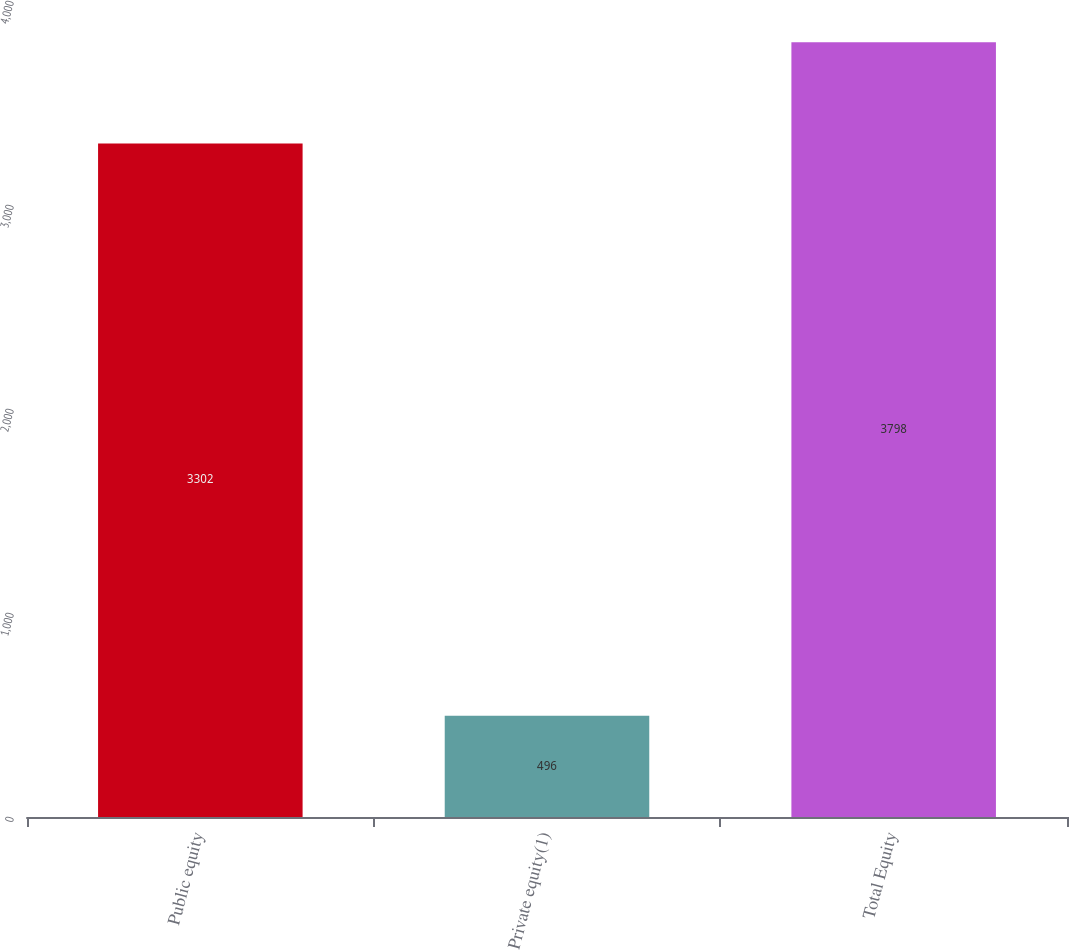Convert chart. <chart><loc_0><loc_0><loc_500><loc_500><bar_chart><fcel>Public equity<fcel>Private equity(1)<fcel>Total Equity<nl><fcel>3302<fcel>496<fcel>3798<nl></chart> 